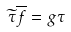Convert formula to latex. <formula><loc_0><loc_0><loc_500><loc_500>\widetilde { \tau } \overline { f } = g \tau</formula> 